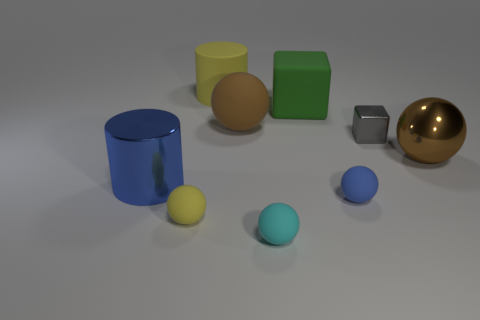Subtract all metallic balls. How many balls are left? 4 Subtract all red cylinders. How many brown balls are left? 2 Subtract all cyan spheres. How many spheres are left? 4 Subtract 1 balls. How many balls are left? 4 Subtract all cubes. How many objects are left? 7 Subtract all purple cubes. Subtract all purple balls. How many cubes are left? 2 Subtract all large brown spheres. Subtract all tiny blue spheres. How many objects are left? 6 Add 9 gray cubes. How many gray cubes are left? 10 Add 7 yellow cylinders. How many yellow cylinders exist? 8 Subtract 0 red balls. How many objects are left? 9 